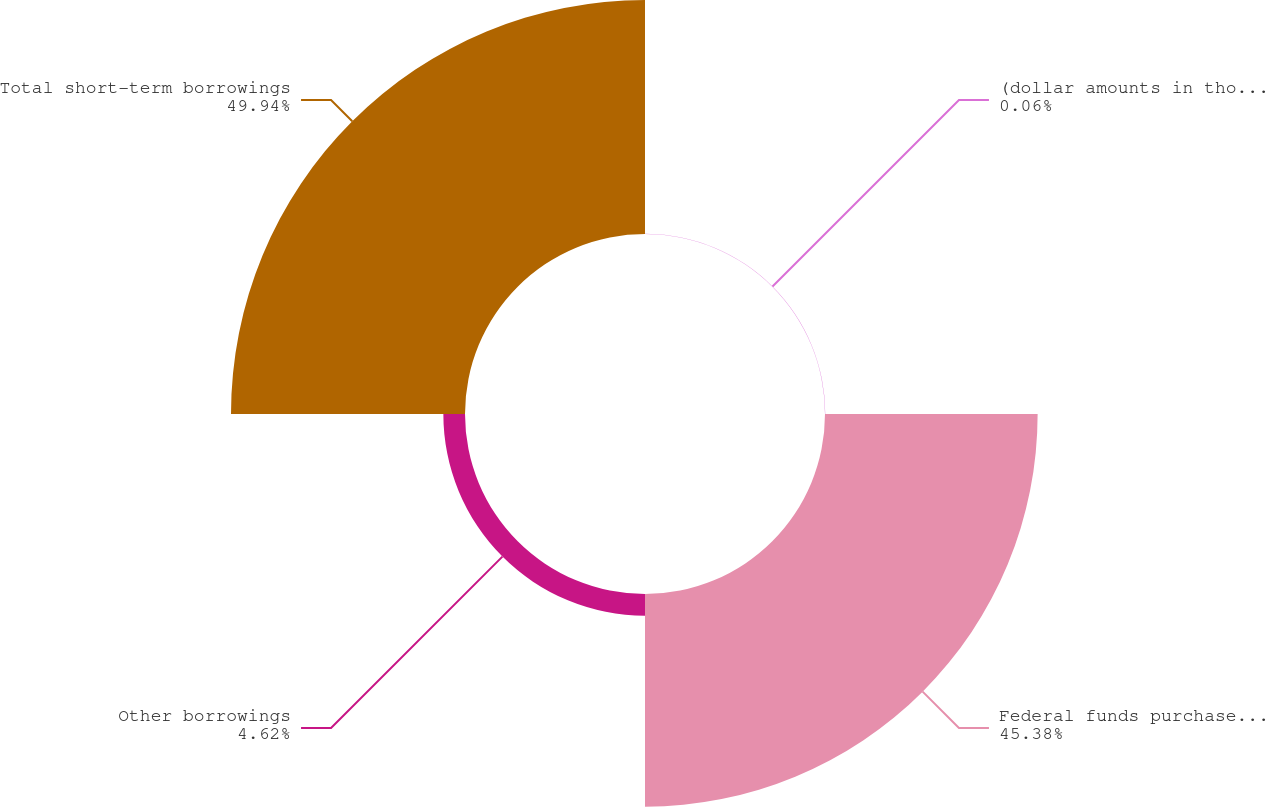Convert chart to OTSL. <chart><loc_0><loc_0><loc_500><loc_500><pie_chart><fcel>(dollar amounts in thousands)<fcel>Federal funds purchased and<fcel>Other borrowings<fcel>Total short-term borrowings<nl><fcel>0.06%<fcel>45.38%<fcel>4.62%<fcel>49.94%<nl></chart> 